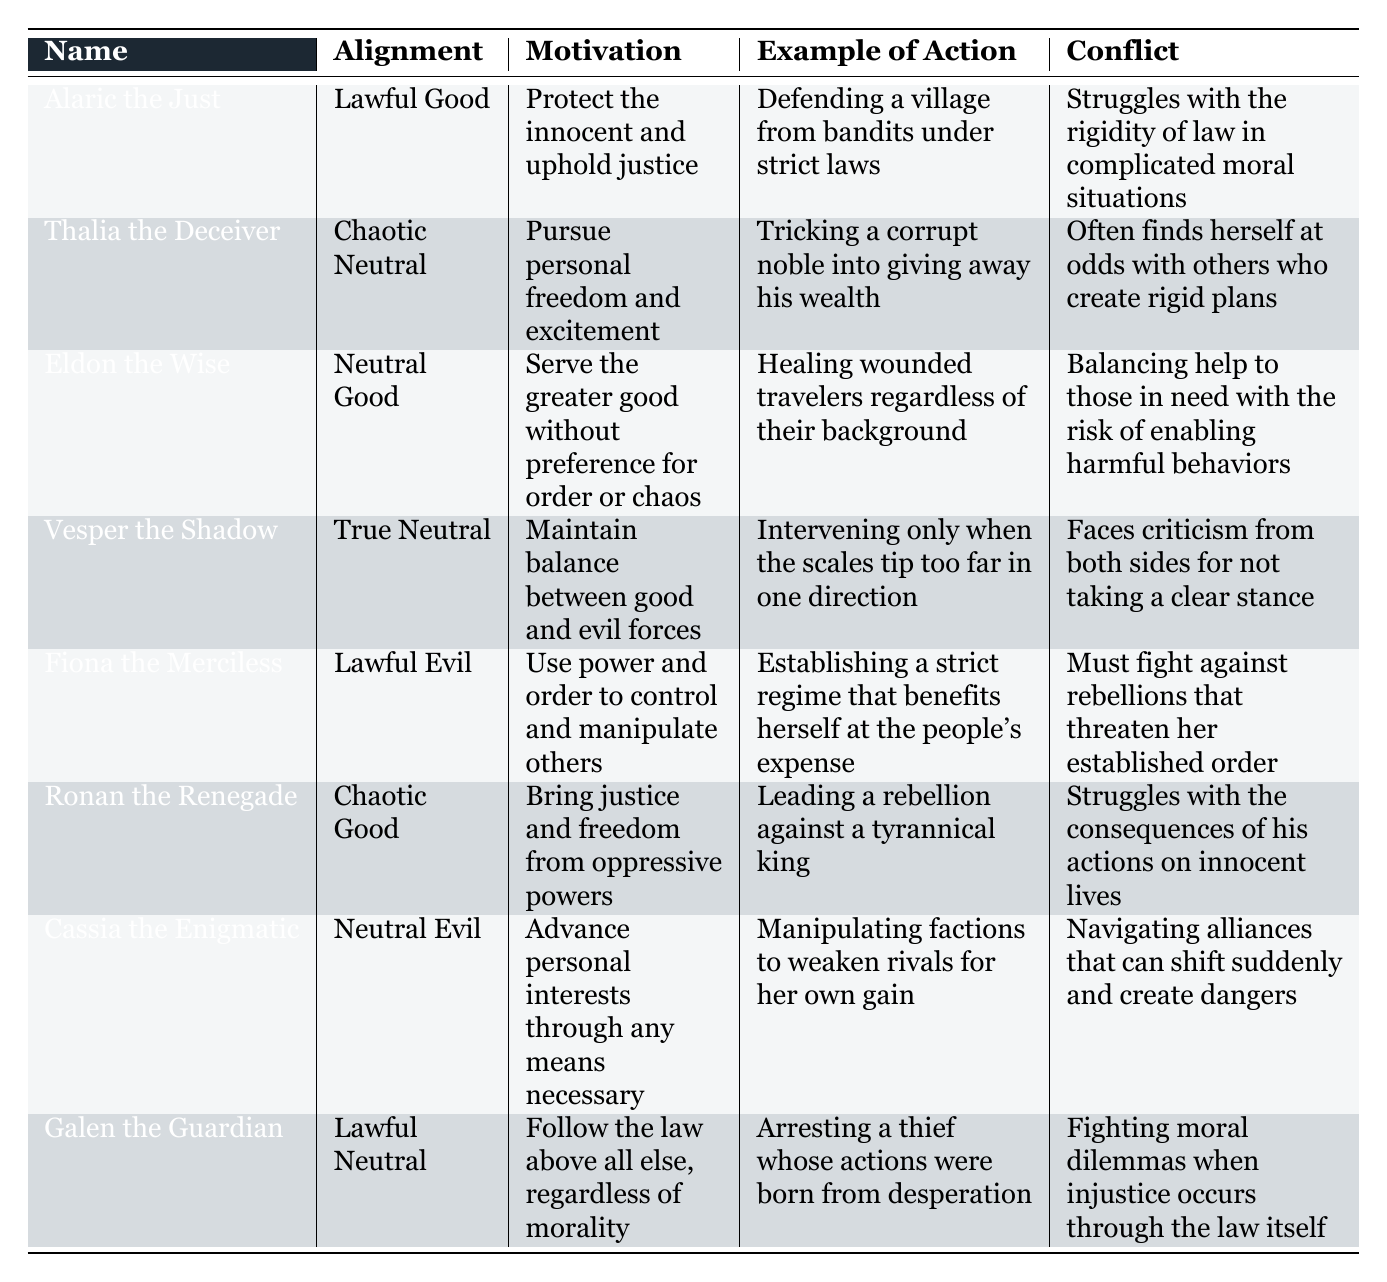What is the motivation of Alaric the Just? The motivation of Alaric the Just is listed directly in the table under his specific row. It states his motivation as "Protect the innocent and uphold justice."
Answer: Protect the innocent and uphold justice How many characters have a "Lawful" alignment? There are three characters with a "Lawful" alignment: Alaric the Just (Lawful Good), Fiona the Merciless (Lawful Evil), and Galen the Guardian (Lawful Neutral). Counting these gives a total of 3 characters.
Answer: 3 Is Vesper the Shadow a Neutral character? Vesper the Shadow's alignment is "True Neutral," which qualifies as a Neutral alignment. Therefore, the statement is true.
Answer: Yes Which character is motivated by the desire for personal freedom? The character motivated by personal freedom is Thalia the Deceiver, whose motivation is "Pursue personal freedom and excitement." This information is found in her row in the table.
Answer: Thalia the Deceiver Which alignment has the most characters listed? When comparing the alignments in the table, the "Neutral" alignment has the most characters: Eldon the Wise (Neutral Good), Vesper the Shadow (True Neutral), and Cassia the Enigmatic (Neutral Evil), totaling 3 characters.
Answer: Neutral What conflict does Ronan the Renegade face? The conflict for Ronan the Renegade is provided in his corresponding row. It states he struggles with "the consequences of his actions on innocent lives."
Answer: The consequences of his actions on innocent lives Which character's action involves healing travelers? The action involving healing travelers is described under Eldon the Wise, who is noted for "Healing wounded travelers regardless of their background."
Answer: Eldon the Wise Is Fiona the Merciless motivated by altruism? Fiona the Merciless's motivation is to "Use power and order to control and manipulate others," which suggests a self-serving rather than altruistic approach, meaning the statement is false.
Answer: No What is the primary conflict faced by Galen the Guardian? Galen the Guardian's conflict, as indicated in the table, involves "Fighting moral dilemmas when injustice occurs through the law itself." This directly outlines his primary struggle.
Answer: Fighting moral dilemmas when injustice occurs through the law itself 